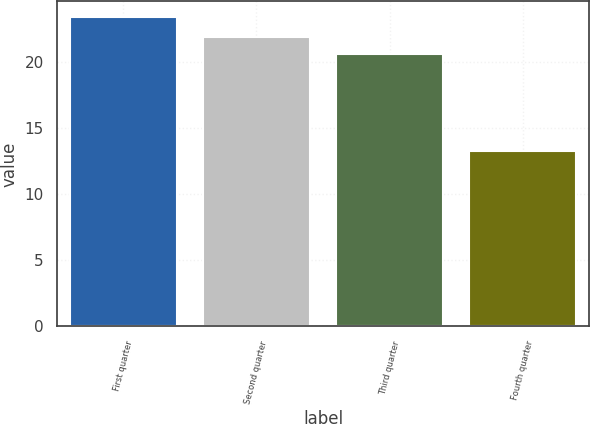Convert chart to OTSL. <chart><loc_0><loc_0><loc_500><loc_500><bar_chart><fcel>First quarter<fcel>Second quarter<fcel>Third quarter<fcel>Fourth quarter<nl><fcel>23.43<fcel>21.92<fcel>20.58<fcel>13.29<nl></chart> 